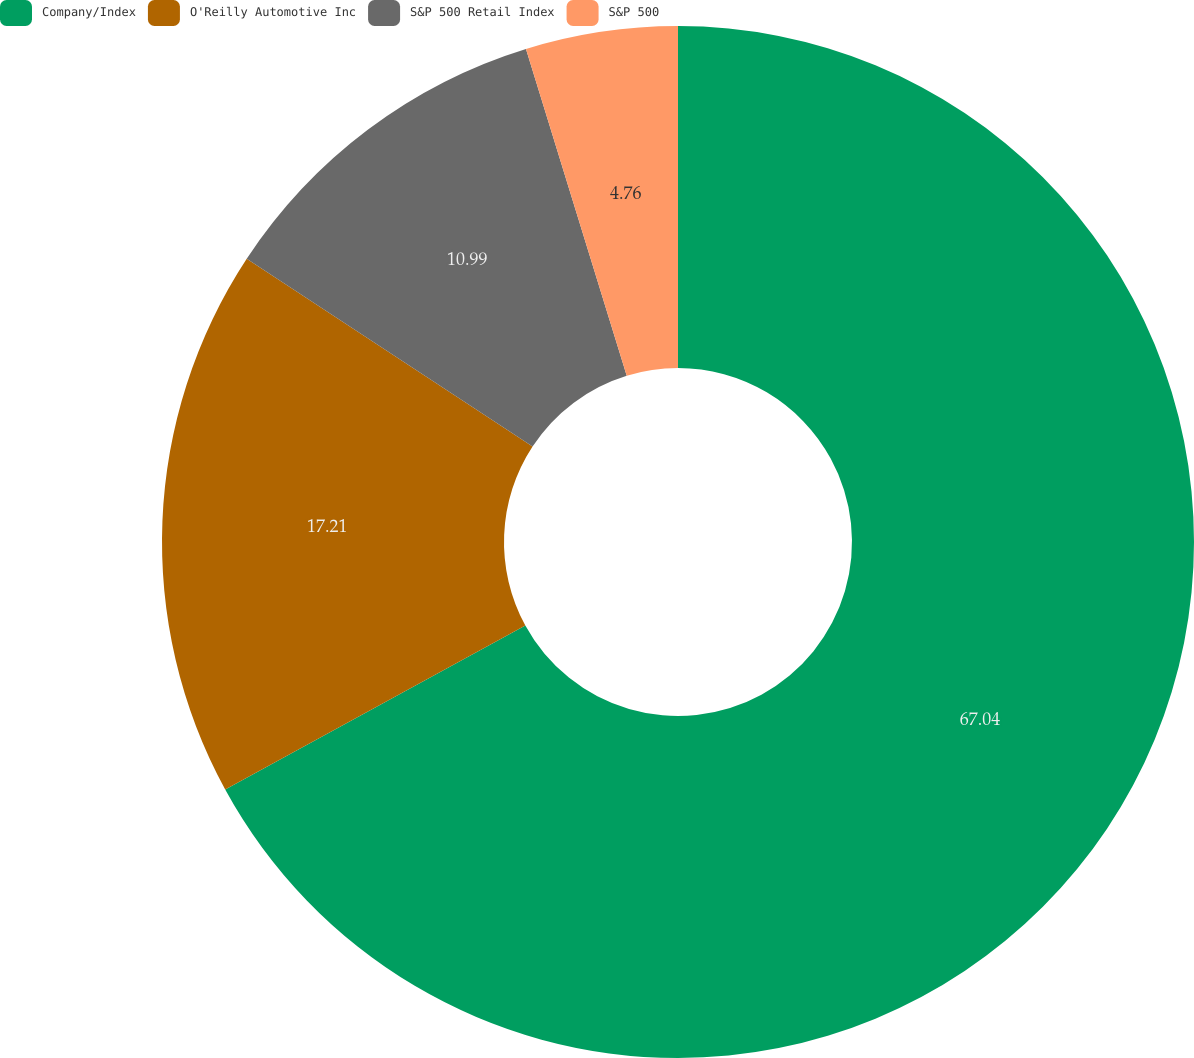Convert chart to OTSL. <chart><loc_0><loc_0><loc_500><loc_500><pie_chart><fcel>Company/Index<fcel>O'Reilly Automotive Inc<fcel>S&P 500 Retail Index<fcel>S&P 500<nl><fcel>67.04%<fcel>17.21%<fcel>10.99%<fcel>4.76%<nl></chart> 